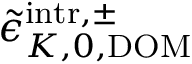Convert formula to latex. <formula><loc_0><loc_0><loc_500><loc_500>\tilde { \epsilon } _ { K , 0 , D O M } ^ { i n t r , \pm }</formula> 